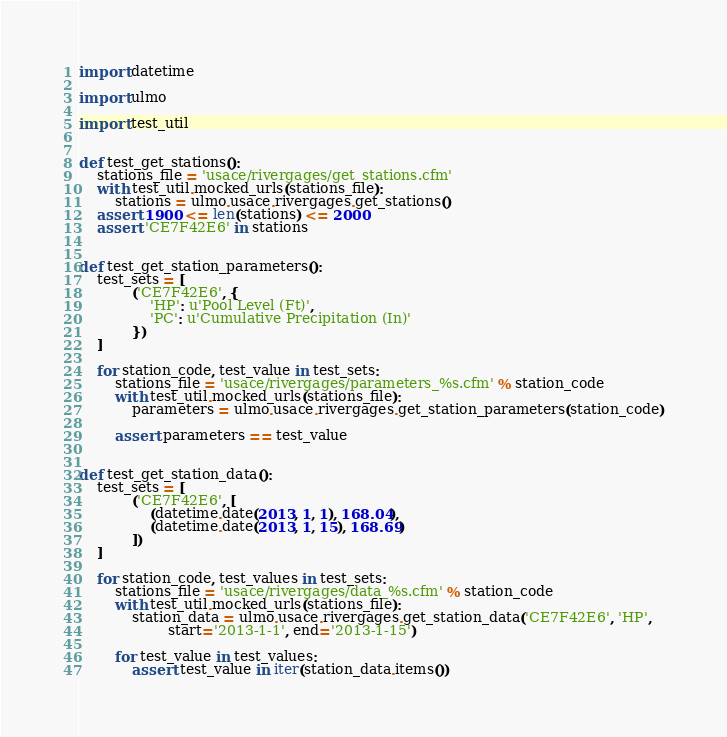<code> <loc_0><loc_0><loc_500><loc_500><_Python_>import datetime

import ulmo

import test_util


def test_get_stations():
    stations_file = 'usace/rivergages/get_stations.cfm'
    with test_util.mocked_urls(stations_file):
        stations = ulmo.usace.rivergages.get_stations()
    assert 1900 <= len(stations) <= 2000
    assert 'CE7F42E6' in stations


def test_get_station_parameters():
    test_sets = [
            ('CE7F42E6', {
                'HP': u'Pool Level (Ft)',
                'PC': u'Cumulative Precipitation (In)'
            })
    ]

    for station_code, test_value in test_sets:
        stations_file = 'usace/rivergages/parameters_%s.cfm' % station_code
        with test_util.mocked_urls(stations_file):
            parameters = ulmo.usace.rivergages.get_station_parameters(station_code)

        assert parameters == test_value


def test_get_station_data():
    test_sets = [
            ('CE7F42E6', [
                (datetime.date(2013, 1, 1), 168.04),
                (datetime.date(2013, 1, 15), 168.69)
            ])
    ]

    for station_code, test_values in test_sets:
        stations_file = 'usace/rivergages/data_%s.cfm' % station_code
        with test_util.mocked_urls(stations_file):
            station_data = ulmo.usace.rivergages.get_station_data('CE7F42E6', 'HP',
                    start='2013-1-1', end='2013-1-15')

        for test_value in test_values:
            assert test_value in iter(station_data.items())
</code> 